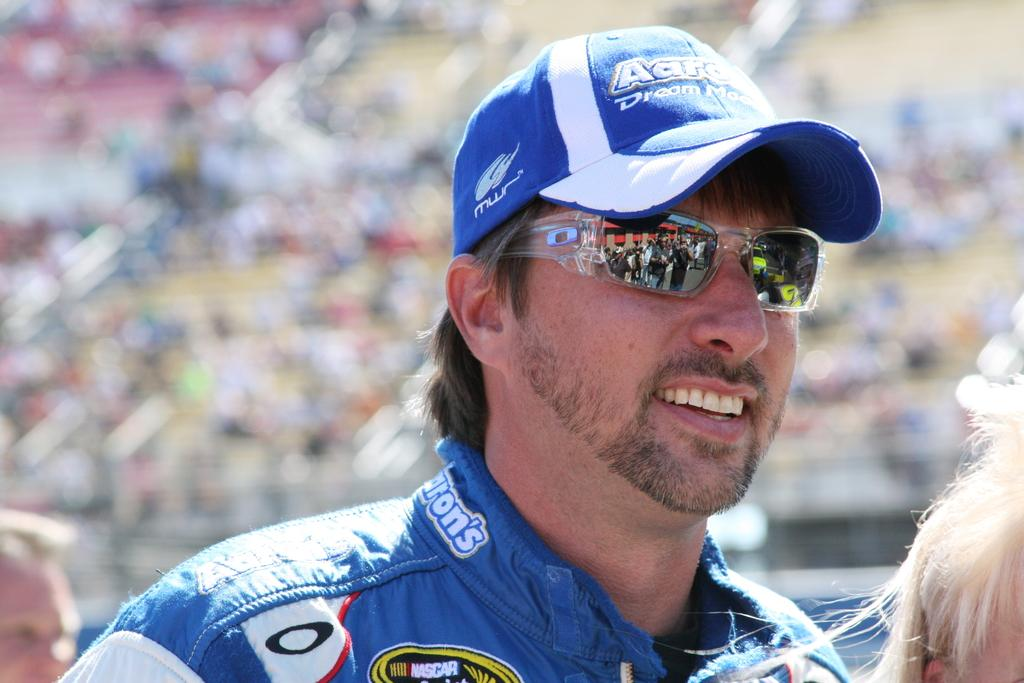Who is present in the image? There is a man in the picture. What is the man wearing on his face? The man is wearing goggles. What type of headwear is the man wearing? The man is wearing a cap. What can be seen in the glass in the image? There is a reflection of people in the glass. How would you describe the background of the image? The background of the image is blurry. What type of pet can be seen in the advertisement in the image? There is no pet or advertisement present in the image. How does the fog affect the visibility in the image? There is no fog present in the image; it is not affecting the visibility. 